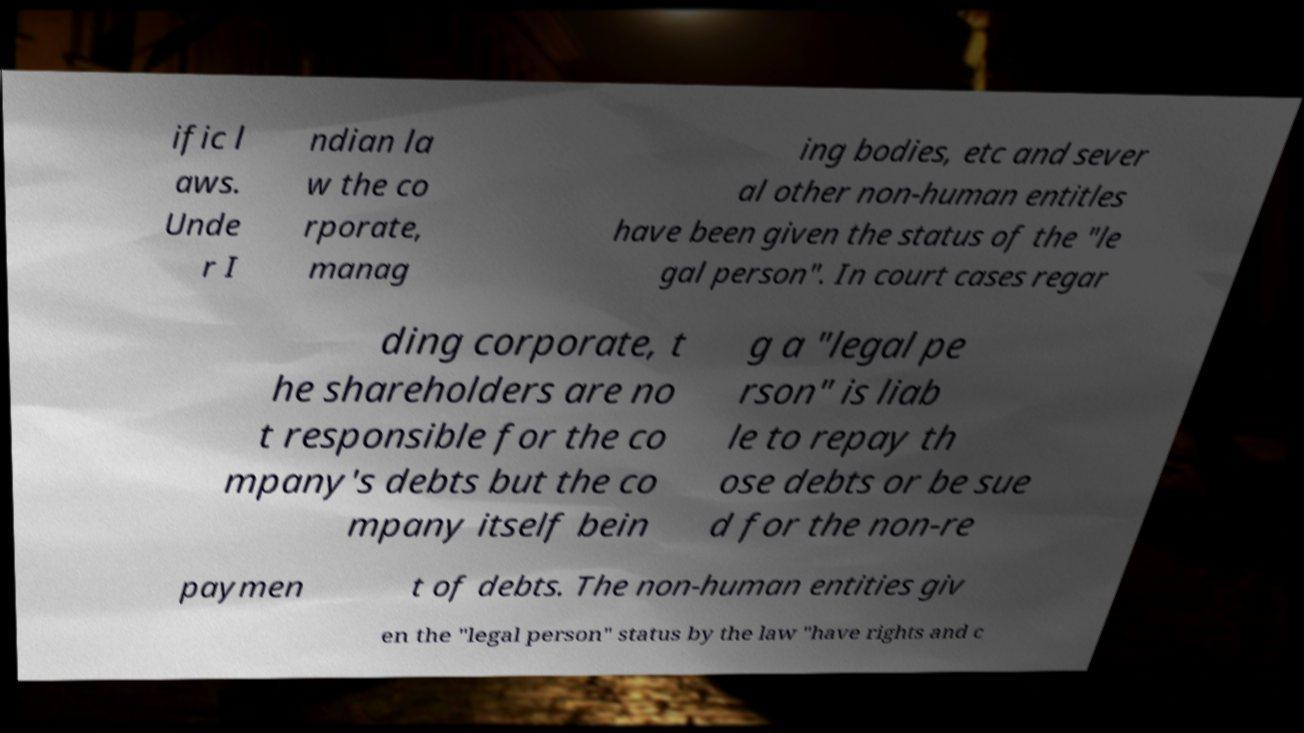Can you read and provide the text displayed in the image?This photo seems to have some interesting text. Can you extract and type it out for me? ific l aws. Unde r I ndian la w the co rporate, manag ing bodies, etc and sever al other non-human entitles have been given the status of the "le gal person". In court cases regar ding corporate, t he shareholders are no t responsible for the co mpany's debts but the co mpany itself bein g a "legal pe rson" is liab le to repay th ose debts or be sue d for the non-re paymen t of debts. The non-human entities giv en the "legal person" status by the law "have rights and c 